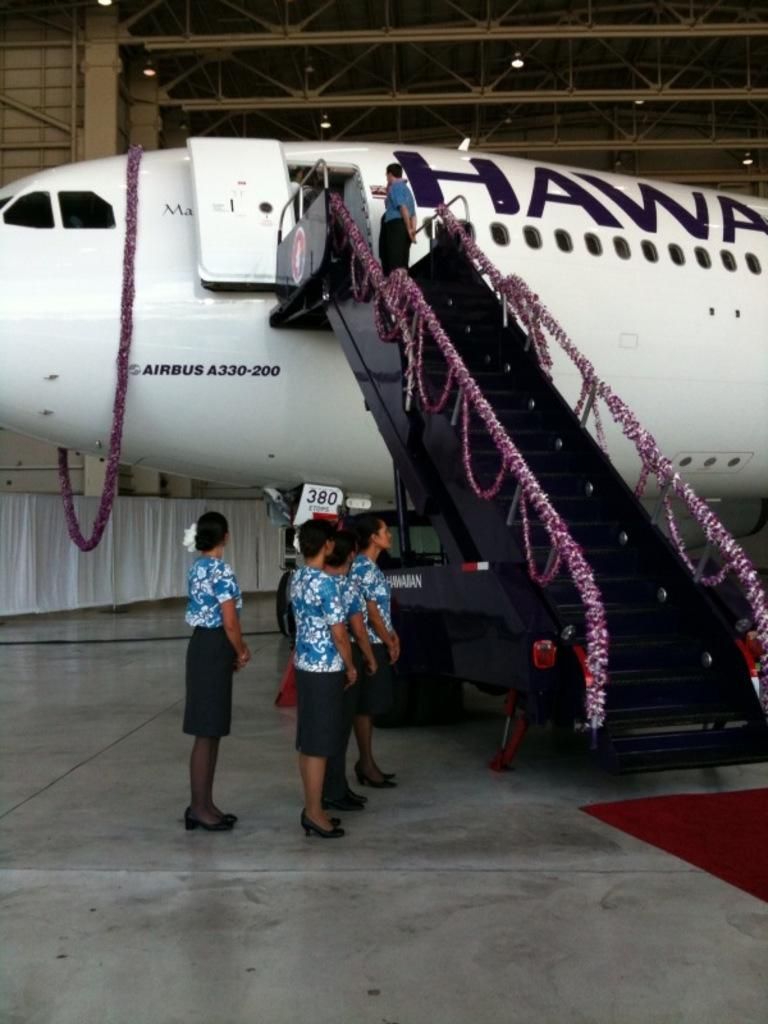What is the main subject of the image? The main subject of the image is an aircraft. What can be seen on the aircraft? There is text written on the aircraft. What is present near the aircraft? There are stairs visible in the image. Who is in the image? There are people standing in the image. What can be seen in the background of the image? There are curtains and a metal fence in the background of the image. How does the aircraft start its engines in the image? The image does not show the aircraft starting its engines; it only shows the aircraft with text on it and its surroundings. 